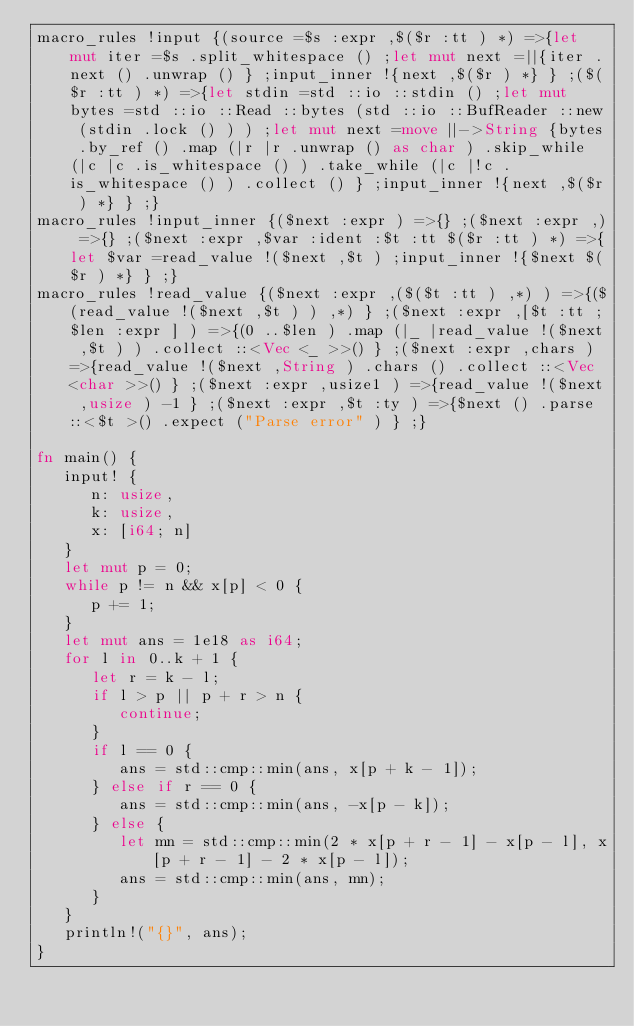Convert code to text. <code><loc_0><loc_0><loc_500><loc_500><_Rust_>macro_rules !input {(source =$s :expr ,$($r :tt ) *) =>{let mut iter =$s .split_whitespace () ;let mut next =||{iter .next () .unwrap () } ;input_inner !{next ,$($r ) *} } ;($($r :tt ) *) =>{let stdin =std ::io ::stdin () ;let mut bytes =std ::io ::Read ::bytes (std ::io ::BufReader ::new (stdin .lock () ) ) ;let mut next =move ||->String {bytes .by_ref () .map (|r |r .unwrap () as char ) .skip_while (|c |c .is_whitespace () ) .take_while (|c |!c .is_whitespace () ) .collect () } ;input_inner !{next ,$($r ) *} } ;}
macro_rules !input_inner {($next :expr ) =>{} ;($next :expr ,) =>{} ;($next :expr ,$var :ident :$t :tt $($r :tt ) *) =>{let $var =read_value !($next ,$t ) ;input_inner !{$next $($r ) *} } ;}
macro_rules !read_value {($next :expr ,($($t :tt ) ,*) ) =>{($(read_value !($next ,$t ) ) ,*) } ;($next :expr ,[$t :tt ;$len :expr ] ) =>{(0 ..$len ) .map (|_ |read_value !($next ,$t ) ) .collect ::<Vec <_ >>() } ;($next :expr ,chars ) =>{read_value !($next ,String ) .chars () .collect ::<Vec <char >>() } ;($next :expr ,usize1 ) =>{read_value !($next ,usize ) -1 } ;($next :expr ,$t :ty ) =>{$next () .parse ::<$t >() .expect ("Parse error" ) } ;}

fn main() {
   input! {
      n: usize,
      k: usize,
      x: [i64; n]
   }
   let mut p = 0;
   while p != n && x[p] < 0 {
      p += 1;
   }
   let mut ans = 1e18 as i64;
   for l in 0..k + 1 {
      let r = k - l;
      if l > p || p + r > n {
         continue;
      }
      if l == 0 {
         ans = std::cmp::min(ans, x[p + k - 1]);
      } else if r == 0 {
         ans = std::cmp::min(ans, -x[p - k]);
      } else {
         let mn = std::cmp::min(2 * x[p + r - 1] - x[p - l], x[p + r - 1] - 2 * x[p - l]);
         ans = std::cmp::min(ans, mn);
      }
   }
   println!("{}", ans);
}
</code> 